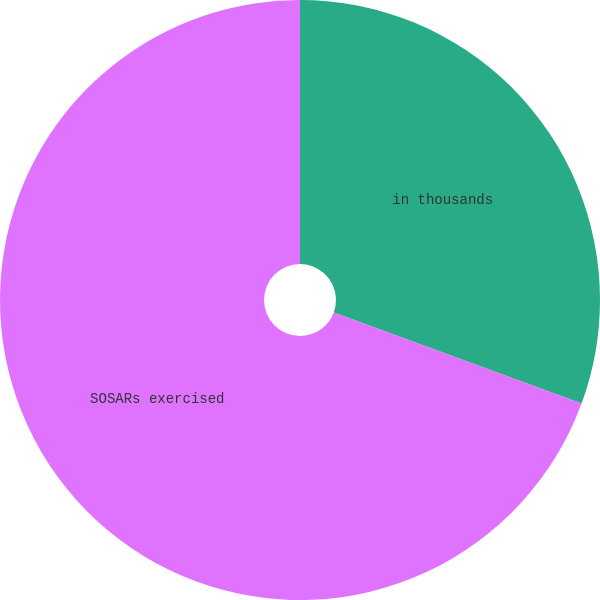Convert chart to OTSL. <chart><loc_0><loc_0><loc_500><loc_500><pie_chart><fcel>in thousands<fcel>SOSARs exercised<nl><fcel>30.61%<fcel>69.39%<nl></chart> 